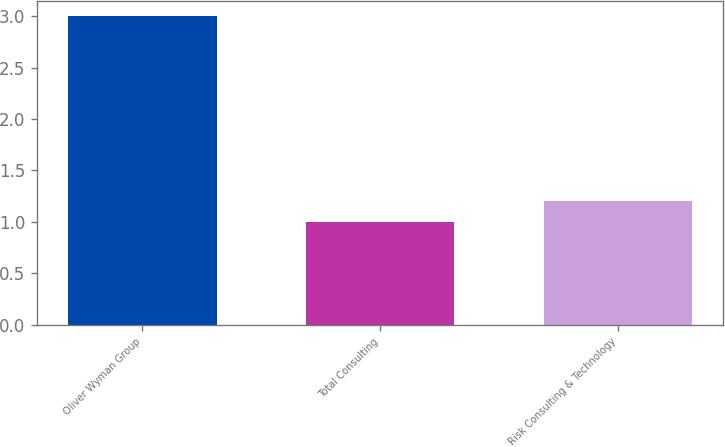Convert chart. <chart><loc_0><loc_0><loc_500><loc_500><bar_chart><fcel>Oliver Wyman Group<fcel>Total Consulting<fcel>Risk Consulting & Technology<nl><fcel>3<fcel>1<fcel>1.2<nl></chart> 